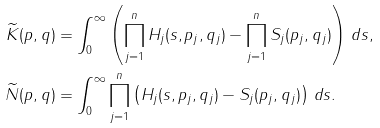Convert formula to latex. <formula><loc_0><loc_0><loc_500><loc_500>\widetilde { K } ( p , q ) & = \int _ { 0 } ^ { \infty } \left ( \prod _ { j = 1 } ^ { n } H _ { j } ( s , p _ { j } , q _ { j } ) - \prod _ { j = 1 } ^ { n } S _ { j } ( p _ { j } , q _ { j } ) \right ) \, d s , \\ \widetilde { N } ( p , q ) & = \int _ { 0 } ^ { \infty } \prod _ { j = 1 } ^ { n } \left ( H _ { j } ( s , p _ { j } , q _ { j } ) - S _ { j } ( p _ { j } , q _ { j } ) \right ) \, d s .</formula> 